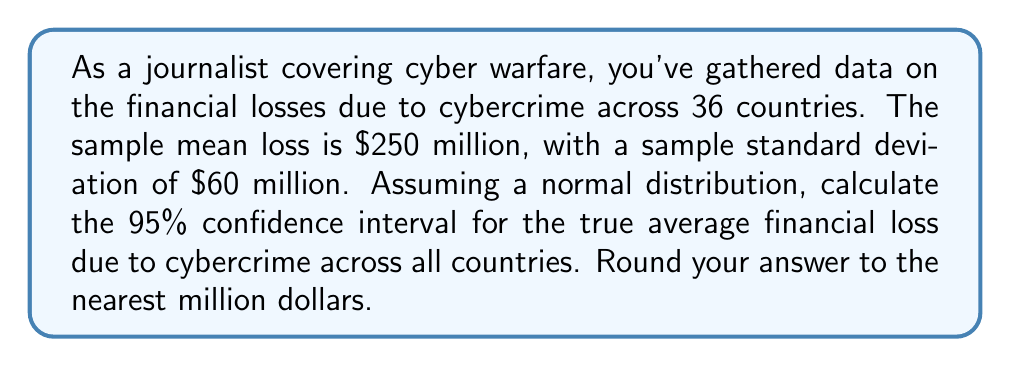Can you solve this math problem? To calculate the confidence interval, we'll use the formula:

$$\text{CI} = \bar{x} \pm t_{\alpha/2} \cdot \frac{s}{\sqrt{n}}$$

Where:
$\bar{x}$ = sample mean = $250 million
$s$ = sample standard deviation = $60 million
$n$ = sample size = 36
$t_{\alpha/2}$ = t-value for 95% confidence interval with 35 degrees of freedom

Step 1: Determine the t-value
For a 95% CI with 35 degrees of freedom, $t_{\alpha/2} = 2.030$ (from t-distribution table)

Step 2: Calculate the margin of error
$$\text{Margin of Error} = t_{\alpha/2} \cdot \frac{s}{\sqrt{n}} = 2.030 \cdot \frac{60}{\sqrt{36}} = 2.030 \cdot 10 = 20.30$$

Step 3: Calculate the confidence interval
Lower bound: $250 - 20.30 = 229.70$
Upper bound: $250 + 20.30 = 270.30$

Step 4: Round to the nearest million
Lower bound: $230 million
Upper bound: $270 million
Answer: ($230 million, $270 million) 